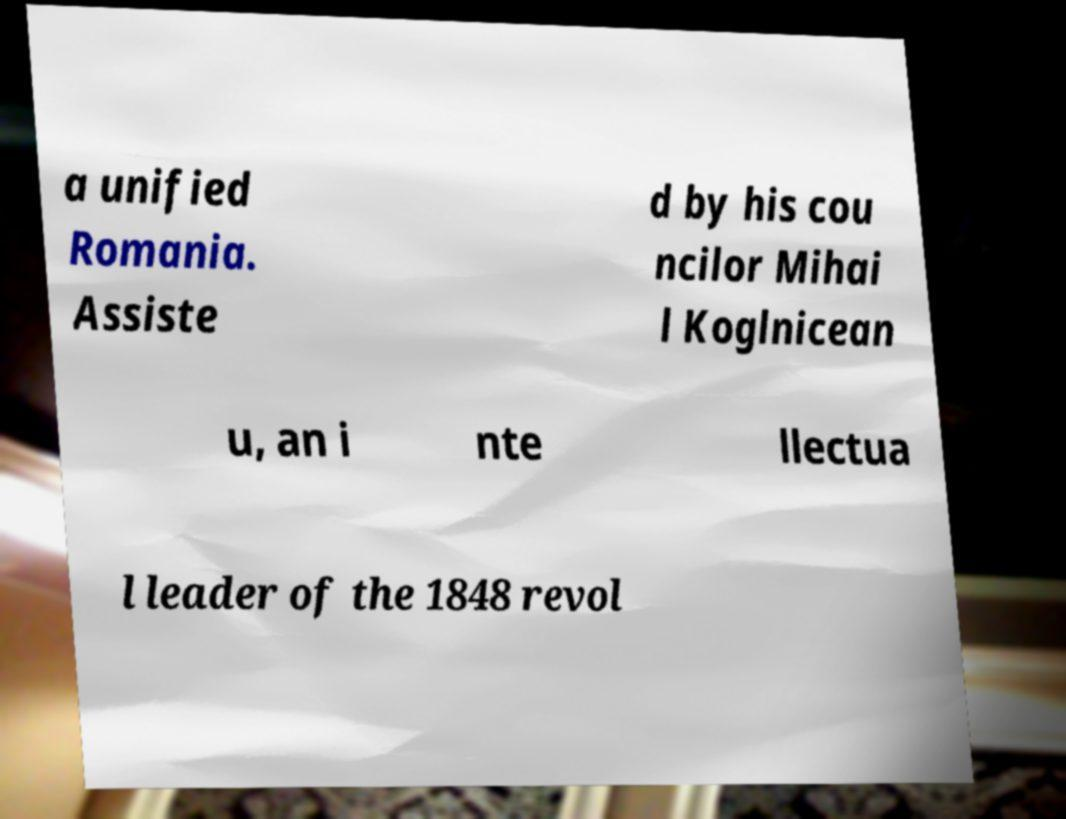Could you extract and type out the text from this image? a unified Romania. Assiste d by his cou ncilor Mihai l Koglnicean u, an i nte llectua l leader of the 1848 revol 